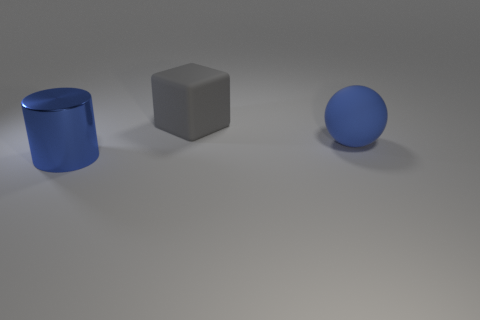Add 2 big cylinders. How many objects exist? 5 Subtract all blocks. How many objects are left? 2 Add 1 small gray shiny things. How many small gray shiny things exist? 1 Subtract 0 green spheres. How many objects are left? 3 Subtract all big matte balls. Subtract all gray matte things. How many objects are left? 1 Add 1 metal objects. How many metal objects are left? 2 